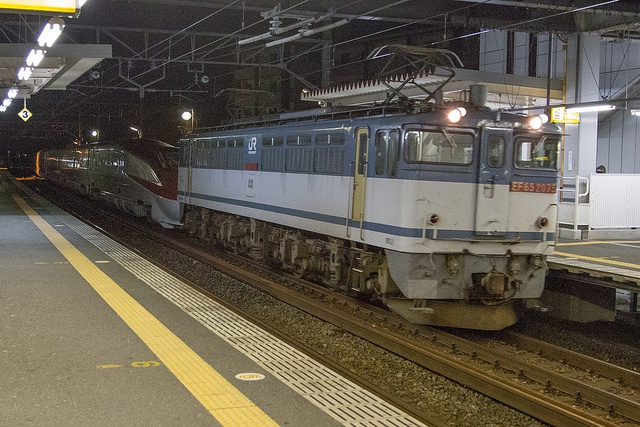Describe the objects in this image and their specific colors. I can see a train in khaki, gray, black, and darkgray tones in this image. 